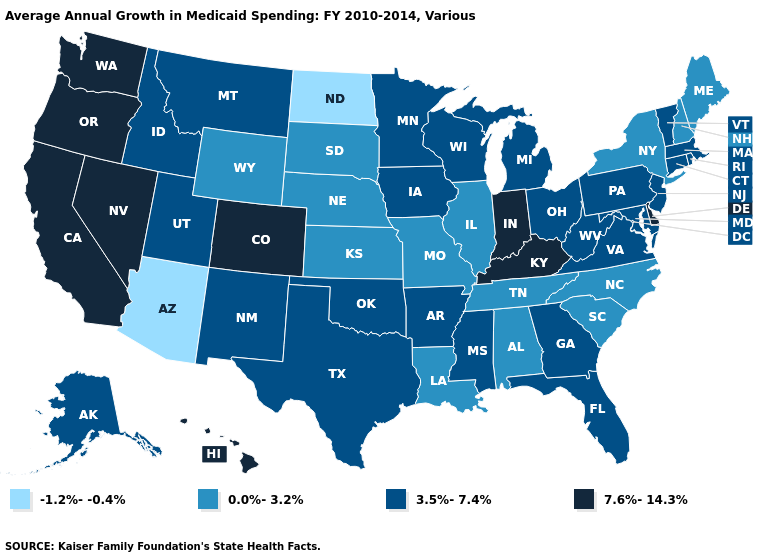Among the states that border Vermont , which have the highest value?
Answer briefly. Massachusetts. Name the states that have a value in the range 3.5%-7.4%?
Keep it brief. Alaska, Arkansas, Connecticut, Florida, Georgia, Idaho, Iowa, Maryland, Massachusetts, Michigan, Minnesota, Mississippi, Montana, New Jersey, New Mexico, Ohio, Oklahoma, Pennsylvania, Rhode Island, Texas, Utah, Vermont, Virginia, West Virginia, Wisconsin. Among the states that border Nebraska , which have the highest value?
Concise answer only. Colorado. What is the value of Maine?
Quick response, please. 0.0%-3.2%. What is the value of New Jersey?
Answer briefly. 3.5%-7.4%. Does the map have missing data?
Give a very brief answer. No. Among the states that border Massachusetts , does Connecticut have the lowest value?
Concise answer only. No. What is the value of California?
Be succinct. 7.6%-14.3%. Name the states that have a value in the range 7.6%-14.3%?
Give a very brief answer. California, Colorado, Delaware, Hawaii, Indiana, Kentucky, Nevada, Oregon, Washington. Which states have the lowest value in the USA?
Answer briefly. Arizona, North Dakota. Does Virginia have the lowest value in the USA?
Keep it brief. No. Does Washington have the lowest value in the West?
Quick response, please. No. Does Indiana have the highest value in the USA?
Keep it brief. Yes. What is the value of Colorado?
Write a very short answer. 7.6%-14.3%. How many symbols are there in the legend?
Concise answer only. 4. 